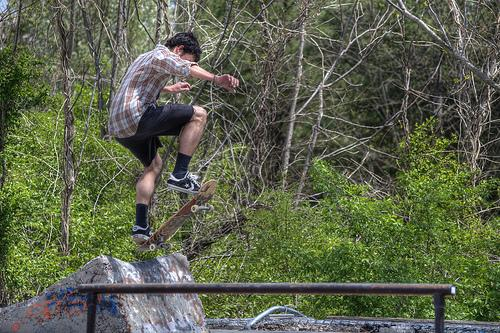What is the condition of the skateboard railing? The skateboard railing is rusty, brown, and made of metal. Can you describe the environment and the feeling of the image? The image has an energetic and adventurous feeling, with a man skateboarding in an outdoor environment surrounded by a forest and rusty railing. How many trees without leaves can be seen in the image? Several trees without leaves can be seen in the image. What colors can you find in the graffiti on the gray rock? The graffiti on the gray rock is orange, red, and blue. List all the key elements present in the image. Man, skateboard, rock, graffiti, rusty railing, trees without leaves, plaid shirt, black shorts, black socks, black Converse shoes, white wheels, forest, and trampoline springs. Can you describe any street art present in the image? There is orange graffiti on a gray rock, which has red and blue colors, as well as graffiti and several designs on the underside of a skateboard. Provide a detailed description of the clothing and footwear the man is wearing. The man is wearing a plaid shirt with rolled-up sleeves, black shorts, black socks, and black Converse shoes. Provide a description of the surroundings of the man and skateboard. There is a rusty railing beside the rock, trees without leaves in the background, a forest, and the springs of a trampoline. Based on the image, is the man in motion or at rest? The man is in motion, skateboarding in mid-air over a rock. Describe the man's position and movement in the image. The man is in mid-air with a skateboard pointing up, his arms extended, and short black hair. 